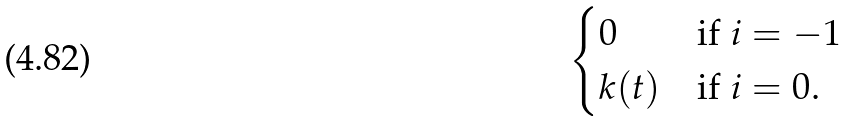Convert formula to latex. <formula><loc_0><loc_0><loc_500><loc_500>\begin{cases} 0 & \text {if $i=-1$} \\ k ( t ) & \text {if $i=0$} . \end{cases}</formula> 